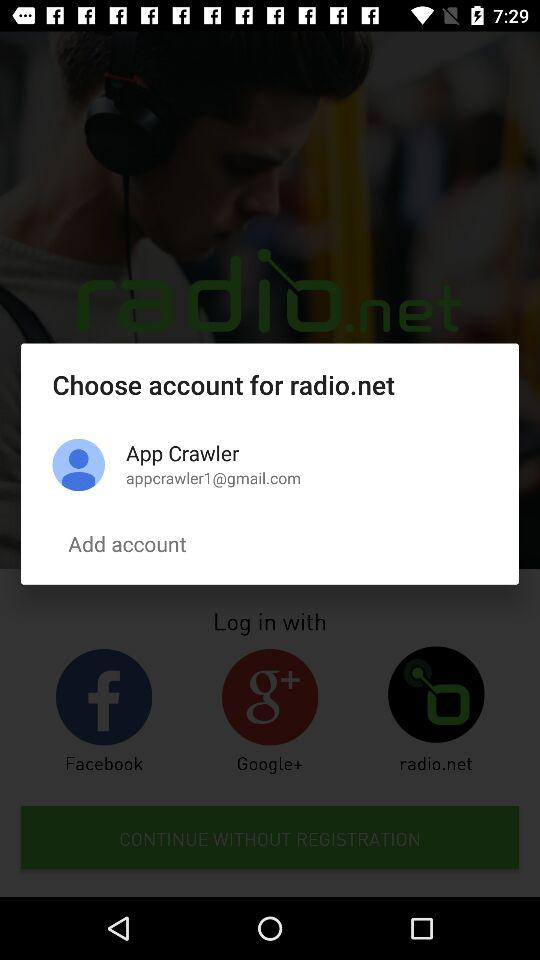How many accounts are there on this screen?
Answer the question using a single word or phrase. 1 